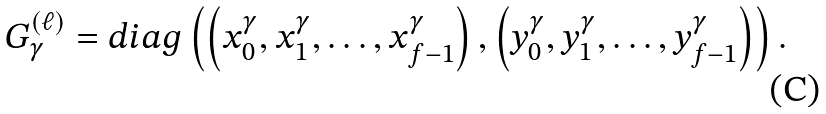Convert formula to latex. <formula><loc_0><loc_0><loc_500><loc_500>G _ { \gamma } ^ { ( \ell ) } = d i a g \left ( \left ( x _ { 0 } ^ { \gamma } , x _ { 1 } ^ { \gamma } , \dots , x _ { f - 1 } ^ { \gamma } \right ) , \left ( y _ { 0 } ^ { \gamma } , y _ { 1 } ^ { \gamma } , \dots , y _ { f - 1 } ^ { \gamma } \right ) \right ) .</formula> 